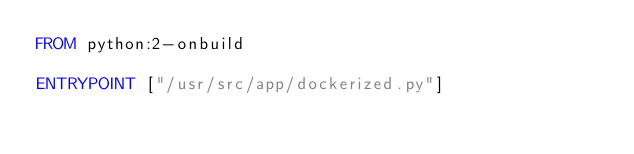Convert code to text. <code><loc_0><loc_0><loc_500><loc_500><_Dockerfile_>FROM python:2-onbuild

ENTRYPOINT ["/usr/src/app/dockerized.py"]
</code> 